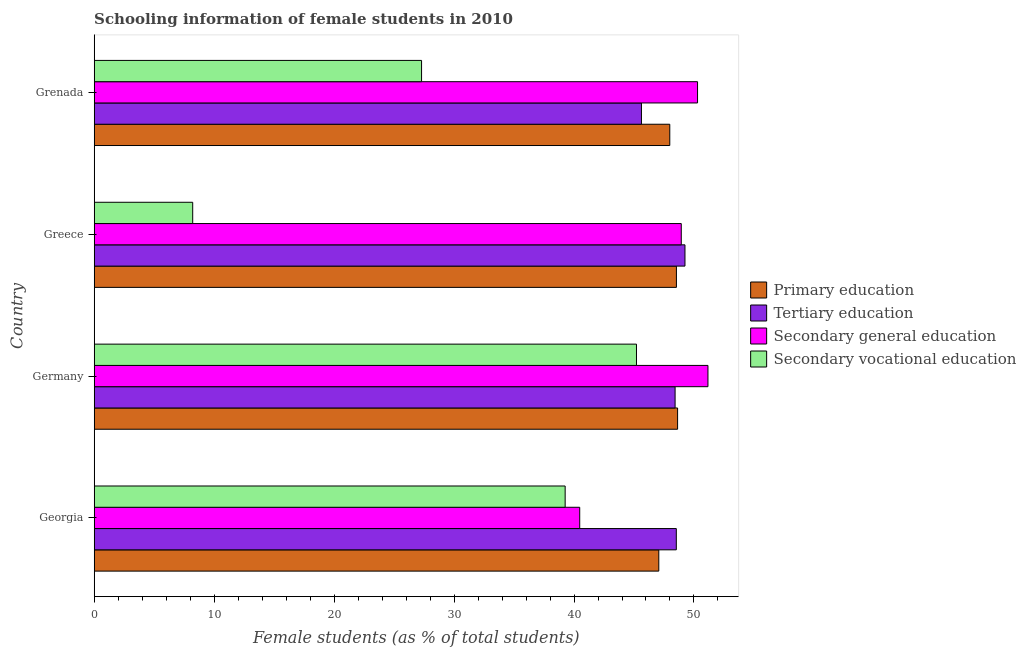How many different coloured bars are there?
Offer a terse response. 4. Are the number of bars per tick equal to the number of legend labels?
Offer a very short reply. Yes. Are the number of bars on each tick of the Y-axis equal?
Offer a terse response. Yes. What is the label of the 1st group of bars from the top?
Offer a terse response. Grenada. In how many cases, is the number of bars for a given country not equal to the number of legend labels?
Provide a short and direct response. 0. What is the percentage of female students in tertiary education in Germany?
Your answer should be compact. 48.43. Across all countries, what is the maximum percentage of female students in secondary vocational education?
Your answer should be very brief. 45.21. Across all countries, what is the minimum percentage of female students in primary education?
Provide a short and direct response. 47.07. In which country was the percentage of female students in secondary vocational education maximum?
Your answer should be compact. Germany. In which country was the percentage of female students in primary education minimum?
Your response must be concise. Georgia. What is the total percentage of female students in primary education in the graph?
Your answer should be compact. 192.22. What is the difference between the percentage of female students in tertiary education in Georgia and that in Greece?
Keep it short and to the point. -0.72. What is the difference between the percentage of female students in secondary education in Germany and the percentage of female students in tertiary education in Greece?
Offer a very short reply. 1.92. What is the average percentage of female students in secondary vocational education per country?
Make the answer very short. 29.99. What is the difference between the percentage of female students in secondary education and percentage of female students in primary education in Greece?
Provide a short and direct response. 0.4. What is the ratio of the percentage of female students in secondary education in Georgia to that in Germany?
Your answer should be compact. 0.79. What is the difference between the highest and the second highest percentage of female students in tertiary education?
Provide a short and direct response. 0.72. What is the difference between the highest and the lowest percentage of female students in primary education?
Offer a terse response. 1.57. In how many countries, is the percentage of female students in primary education greater than the average percentage of female students in primary education taken over all countries?
Offer a terse response. 2. Is the sum of the percentage of female students in secondary vocational education in Georgia and Grenada greater than the maximum percentage of female students in tertiary education across all countries?
Your response must be concise. Yes. Is it the case that in every country, the sum of the percentage of female students in secondary vocational education and percentage of female students in secondary education is greater than the sum of percentage of female students in tertiary education and percentage of female students in primary education?
Your response must be concise. No. What does the 1st bar from the top in Greece represents?
Offer a terse response. Secondary vocational education. Is it the case that in every country, the sum of the percentage of female students in primary education and percentage of female students in tertiary education is greater than the percentage of female students in secondary education?
Offer a very short reply. Yes. How many countries are there in the graph?
Your response must be concise. 4. Does the graph contain any zero values?
Offer a terse response. No. Where does the legend appear in the graph?
Give a very brief answer. Center right. How many legend labels are there?
Your answer should be compact. 4. How are the legend labels stacked?
Provide a short and direct response. Vertical. What is the title of the graph?
Ensure brevity in your answer.  Schooling information of female students in 2010. Does "Interest Payments" appear as one of the legend labels in the graph?
Keep it short and to the point. No. What is the label or title of the X-axis?
Offer a terse response. Female students (as % of total students). What is the label or title of the Y-axis?
Offer a very short reply. Country. What is the Female students (as % of total students) in Primary education in Georgia?
Provide a short and direct response. 47.07. What is the Female students (as % of total students) in Tertiary education in Georgia?
Provide a succinct answer. 48.53. What is the Female students (as % of total students) of Secondary general education in Georgia?
Your answer should be very brief. 40.47. What is the Female students (as % of total students) of Secondary vocational education in Georgia?
Your response must be concise. 39.26. What is the Female students (as % of total students) in Primary education in Germany?
Your answer should be very brief. 48.63. What is the Female students (as % of total students) of Tertiary education in Germany?
Your answer should be very brief. 48.43. What is the Female students (as % of total students) in Secondary general education in Germany?
Offer a terse response. 51.16. What is the Female students (as % of total students) of Secondary vocational education in Germany?
Provide a succinct answer. 45.21. What is the Female students (as % of total students) of Primary education in Greece?
Offer a very short reply. 48.54. What is the Female students (as % of total students) of Tertiary education in Greece?
Keep it short and to the point. 49.25. What is the Female students (as % of total students) of Secondary general education in Greece?
Make the answer very short. 48.94. What is the Female students (as % of total students) in Secondary vocational education in Greece?
Your answer should be very brief. 8.21. What is the Female students (as % of total students) of Primary education in Grenada?
Provide a succinct answer. 47.98. What is the Female students (as % of total students) in Tertiary education in Grenada?
Keep it short and to the point. 45.62. What is the Female students (as % of total students) in Secondary general education in Grenada?
Provide a short and direct response. 50.3. What is the Female students (as % of total students) of Secondary vocational education in Grenada?
Keep it short and to the point. 27.29. Across all countries, what is the maximum Female students (as % of total students) in Primary education?
Your response must be concise. 48.63. Across all countries, what is the maximum Female students (as % of total students) of Tertiary education?
Make the answer very short. 49.25. Across all countries, what is the maximum Female students (as % of total students) in Secondary general education?
Your answer should be compact. 51.16. Across all countries, what is the maximum Female students (as % of total students) of Secondary vocational education?
Provide a succinct answer. 45.21. Across all countries, what is the minimum Female students (as % of total students) in Primary education?
Keep it short and to the point. 47.07. Across all countries, what is the minimum Female students (as % of total students) of Tertiary education?
Offer a very short reply. 45.62. Across all countries, what is the minimum Female students (as % of total students) of Secondary general education?
Your response must be concise. 40.47. Across all countries, what is the minimum Female students (as % of total students) in Secondary vocational education?
Your answer should be compact. 8.21. What is the total Female students (as % of total students) in Primary education in the graph?
Keep it short and to the point. 192.22. What is the total Female students (as % of total students) of Tertiary education in the graph?
Offer a very short reply. 191.82. What is the total Female students (as % of total students) in Secondary general education in the graph?
Offer a very short reply. 190.88. What is the total Female students (as % of total students) of Secondary vocational education in the graph?
Your answer should be very brief. 119.97. What is the difference between the Female students (as % of total students) in Primary education in Georgia and that in Germany?
Your answer should be very brief. -1.57. What is the difference between the Female students (as % of total students) in Tertiary education in Georgia and that in Germany?
Give a very brief answer. 0.1. What is the difference between the Female students (as % of total students) of Secondary general education in Georgia and that in Germany?
Offer a terse response. -10.69. What is the difference between the Female students (as % of total students) in Secondary vocational education in Georgia and that in Germany?
Offer a terse response. -5.95. What is the difference between the Female students (as % of total students) in Primary education in Georgia and that in Greece?
Offer a terse response. -1.47. What is the difference between the Female students (as % of total students) in Tertiary education in Georgia and that in Greece?
Provide a succinct answer. -0.72. What is the difference between the Female students (as % of total students) in Secondary general education in Georgia and that in Greece?
Provide a short and direct response. -8.47. What is the difference between the Female students (as % of total students) in Secondary vocational education in Georgia and that in Greece?
Your answer should be compact. 31.05. What is the difference between the Female students (as % of total students) of Primary education in Georgia and that in Grenada?
Give a very brief answer. -0.92. What is the difference between the Female students (as % of total students) in Tertiary education in Georgia and that in Grenada?
Give a very brief answer. 2.91. What is the difference between the Female students (as % of total students) of Secondary general education in Georgia and that in Grenada?
Provide a short and direct response. -9.82. What is the difference between the Female students (as % of total students) in Secondary vocational education in Georgia and that in Grenada?
Keep it short and to the point. 11.97. What is the difference between the Female students (as % of total students) of Primary education in Germany and that in Greece?
Offer a terse response. 0.1. What is the difference between the Female students (as % of total students) in Tertiary education in Germany and that in Greece?
Ensure brevity in your answer.  -0.82. What is the difference between the Female students (as % of total students) in Secondary general education in Germany and that in Greece?
Give a very brief answer. 2.22. What is the difference between the Female students (as % of total students) of Secondary vocational education in Germany and that in Greece?
Your answer should be very brief. 36.99. What is the difference between the Female students (as % of total students) in Primary education in Germany and that in Grenada?
Provide a succinct answer. 0.65. What is the difference between the Female students (as % of total students) in Tertiary education in Germany and that in Grenada?
Your answer should be compact. 2.8. What is the difference between the Female students (as % of total students) in Secondary general education in Germany and that in Grenada?
Offer a terse response. 0.87. What is the difference between the Female students (as % of total students) of Secondary vocational education in Germany and that in Grenada?
Your response must be concise. 17.92. What is the difference between the Female students (as % of total students) of Primary education in Greece and that in Grenada?
Provide a succinct answer. 0.55. What is the difference between the Female students (as % of total students) in Tertiary education in Greece and that in Grenada?
Give a very brief answer. 3.63. What is the difference between the Female students (as % of total students) of Secondary general education in Greece and that in Grenada?
Provide a short and direct response. -1.36. What is the difference between the Female students (as % of total students) in Secondary vocational education in Greece and that in Grenada?
Provide a succinct answer. -19.08. What is the difference between the Female students (as % of total students) of Primary education in Georgia and the Female students (as % of total students) of Tertiary education in Germany?
Your response must be concise. -1.36. What is the difference between the Female students (as % of total students) in Primary education in Georgia and the Female students (as % of total students) in Secondary general education in Germany?
Your answer should be very brief. -4.1. What is the difference between the Female students (as % of total students) in Primary education in Georgia and the Female students (as % of total students) in Secondary vocational education in Germany?
Your response must be concise. 1.86. What is the difference between the Female students (as % of total students) of Tertiary education in Georgia and the Female students (as % of total students) of Secondary general education in Germany?
Ensure brevity in your answer.  -2.64. What is the difference between the Female students (as % of total students) of Tertiary education in Georgia and the Female students (as % of total students) of Secondary vocational education in Germany?
Your answer should be very brief. 3.32. What is the difference between the Female students (as % of total students) in Secondary general education in Georgia and the Female students (as % of total students) in Secondary vocational education in Germany?
Offer a very short reply. -4.73. What is the difference between the Female students (as % of total students) in Primary education in Georgia and the Female students (as % of total students) in Tertiary education in Greece?
Give a very brief answer. -2.18. What is the difference between the Female students (as % of total students) of Primary education in Georgia and the Female students (as % of total students) of Secondary general education in Greece?
Provide a succinct answer. -1.87. What is the difference between the Female students (as % of total students) of Primary education in Georgia and the Female students (as % of total students) of Secondary vocational education in Greece?
Give a very brief answer. 38.85. What is the difference between the Female students (as % of total students) in Tertiary education in Georgia and the Female students (as % of total students) in Secondary general education in Greece?
Your answer should be very brief. -0.41. What is the difference between the Female students (as % of total students) in Tertiary education in Georgia and the Female students (as % of total students) in Secondary vocational education in Greece?
Give a very brief answer. 40.31. What is the difference between the Female students (as % of total students) in Secondary general education in Georgia and the Female students (as % of total students) in Secondary vocational education in Greece?
Ensure brevity in your answer.  32.26. What is the difference between the Female students (as % of total students) of Primary education in Georgia and the Female students (as % of total students) of Tertiary education in Grenada?
Provide a short and direct response. 1.45. What is the difference between the Female students (as % of total students) in Primary education in Georgia and the Female students (as % of total students) in Secondary general education in Grenada?
Keep it short and to the point. -3.23. What is the difference between the Female students (as % of total students) of Primary education in Georgia and the Female students (as % of total students) of Secondary vocational education in Grenada?
Your answer should be very brief. 19.78. What is the difference between the Female students (as % of total students) in Tertiary education in Georgia and the Female students (as % of total students) in Secondary general education in Grenada?
Offer a terse response. -1.77. What is the difference between the Female students (as % of total students) in Tertiary education in Georgia and the Female students (as % of total students) in Secondary vocational education in Grenada?
Offer a very short reply. 21.24. What is the difference between the Female students (as % of total students) of Secondary general education in Georgia and the Female students (as % of total students) of Secondary vocational education in Grenada?
Offer a terse response. 13.18. What is the difference between the Female students (as % of total students) in Primary education in Germany and the Female students (as % of total students) in Tertiary education in Greece?
Provide a succinct answer. -0.61. What is the difference between the Female students (as % of total students) in Primary education in Germany and the Female students (as % of total students) in Secondary general education in Greece?
Keep it short and to the point. -0.31. What is the difference between the Female students (as % of total students) in Primary education in Germany and the Female students (as % of total students) in Secondary vocational education in Greece?
Provide a succinct answer. 40.42. What is the difference between the Female students (as % of total students) in Tertiary education in Germany and the Female students (as % of total students) in Secondary general education in Greece?
Give a very brief answer. -0.52. What is the difference between the Female students (as % of total students) in Tertiary education in Germany and the Female students (as % of total students) in Secondary vocational education in Greece?
Offer a terse response. 40.21. What is the difference between the Female students (as % of total students) in Secondary general education in Germany and the Female students (as % of total students) in Secondary vocational education in Greece?
Keep it short and to the point. 42.95. What is the difference between the Female students (as % of total students) in Primary education in Germany and the Female students (as % of total students) in Tertiary education in Grenada?
Your answer should be compact. 3.01. What is the difference between the Female students (as % of total students) of Primary education in Germany and the Female students (as % of total students) of Secondary general education in Grenada?
Provide a short and direct response. -1.66. What is the difference between the Female students (as % of total students) of Primary education in Germany and the Female students (as % of total students) of Secondary vocational education in Grenada?
Keep it short and to the point. 21.34. What is the difference between the Female students (as % of total students) in Tertiary education in Germany and the Female students (as % of total students) in Secondary general education in Grenada?
Give a very brief answer. -1.87. What is the difference between the Female students (as % of total students) of Tertiary education in Germany and the Female students (as % of total students) of Secondary vocational education in Grenada?
Provide a succinct answer. 21.14. What is the difference between the Female students (as % of total students) in Secondary general education in Germany and the Female students (as % of total students) in Secondary vocational education in Grenada?
Keep it short and to the point. 23.87. What is the difference between the Female students (as % of total students) of Primary education in Greece and the Female students (as % of total students) of Tertiary education in Grenada?
Offer a very short reply. 2.92. What is the difference between the Female students (as % of total students) of Primary education in Greece and the Female students (as % of total students) of Secondary general education in Grenada?
Your response must be concise. -1.76. What is the difference between the Female students (as % of total students) of Primary education in Greece and the Female students (as % of total students) of Secondary vocational education in Grenada?
Provide a succinct answer. 21.25. What is the difference between the Female students (as % of total students) of Tertiary education in Greece and the Female students (as % of total students) of Secondary general education in Grenada?
Provide a succinct answer. -1.05. What is the difference between the Female students (as % of total students) in Tertiary education in Greece and the Female students (as % of total students) in Secondary vocational education in Grenada?
Offer a terse response. 21.96. What is the difference between the Female students (as % of total students) in Secondary general education in Greece and the Female students (as % of total students) in Secondary vocational education in Grenada?
Your answer should be compact. 21.65. What is the average Female students (as % of total students) in Primary education per country?
Provide a short and direct response. 48.06. What is the average Female students (as % of total students) of Tertiary education per country?
Your answer should be very brief. 47.96. What is the average Female students (as % of total students) of Secondary general education per country?
Ensure brevity in your answer.  47.72. What is the average Female students (as % of total students) in Secondary vocational education per country?
Provide a short and direct response. 29.99. What is the difference between the Female students (as % of total students) of Primary education and Female students (as % of total students) of Tertiary education in Georgia?
Ensure brevity in your answer.  -1.46. What is the difference between the Female students (as % of total students) in Primary education and Female students (as % of total students) in Secondary general education in Georgia?
Your answer should be compact. 6.59. What is the difference between the Female students (as % of total students) in Primary education and Female students (as % of total students) in Secondary vocational education in Georgia?
Offer a terse response. 7.81. What is the difference between the Female students (as % of total students) of Tertiary education and Female students (as % of total students) of Secondary general education in Georgia?
Offer a very short reply. 8.05. What is the difference between the Female students (as % of total students) in Tertiary education and Female students (as % of total students) in Secondary vocational education in Georgia?
Offer a terse response. 9.27. What is the difference between the Female students (as % of total students) of Secondary general education and Female students (as % of total students) of Secondary vocational education in Georgia?
Ensure brevity in your answer.  1.21. What is the difference between the Female students (as % of total students) of Primary education and Female students (as % of total students) of Tertiary education in Germany?
Provide a succinct answer. 0.21. What is the difference between the Female students (as % of total students) in Primary education and Female students (as % of total students) in Secondary general education in Germany?
Your answer should be compact. -2.53. What is the difference between the Female students (as % of total students) of Primary education and Female students (as % of total students) of Secondary vocational education in Germany?
Give a very brief answer. 3.43. What is the difference between the Female students (as % of total students) of Tertiary education and Female students (as % of total students) of Secondary general education in Germany?
Make the answer very short. -2.74. What is the difference between the Female students (as % of total students) of Tertiary education and Female students (as % of total students) of Secondary vocational education in Germany?
Your response must be concise. 3.22. What is the difference between the Female students (as % of total students) of Secondary general education and Female students (as % of total students) of Secondary vocational education in Germany?
Ensure brevity in your answer.  5.96. What is the difference between the Female students (as % of total students) of Primary education and Female students (as % of total students) of Tertiary education in Greece?
Your response must be concise. -0.71. What is the difference between the Female students (as % of total students) in Primary education and Female students (as % of total students) in Secondary general education in Greece?
Your answer should be very brief. -0.4. What is the difference between the Female students (as % of total students) of Primary education and Female students (as % of total students) of Secondary vocational education in Greece?
Give a very brief answer. 40.33. What is the difference between the Female students (as % of total students) of Tertiary education and Female students (as % of total students) of Secondary general education in Greece?
Give a very brief answer. 0.31. What is the difference between the Female students (as % of total students) in Tertiary education and Female students (as % of total students) in Secondary vocational education in Greece?
Provide a succinct answer. 41.04. What is the difference between the Female students (as % of total students) in Secondary general education and Female students (as % of total students) in Secondary vocational education in Greece?
Your answer should be very brief. 40.73. What is the difference between the Female students (as % of total students) of Primary education and Female students (as % of total students) of Tertiary education in Grenada?
Offer a terse response. 2.36. What is the difference between the Female students (as % of total students) in Primary education and Female students (as % of total students) in Secondary general education in Grenada?
Provide a succinct answer. -2.31. What is the difference between the Female students (as % of total students) in Primary education and Female students (as % of total students) in Secondary vocational education in Grenada?
Give a very brief answer. 20.69. What is the difference between the Female students (as % of total students) of Tertiary education and Female students (as % of total students) of Secondary general education in Grenada?
Provide a short and direct response. -4.68. What is the difference between the Female students (as % of total students) of Tertiary education and Female students (as % of total students) of Secondary vocational education in Grenada?
Your answer should be compact. 18.33. What is the difference between the Female students (as % of total students) in Secondary general education and Female students (as % of total students) in Secondary vocational education in Grenada?
Offer a terse response. 23.01. What is the ratio of the Female students (as % of total students) of Primary education in Georgia to that in Germany?
Provide a succinct answer. 0.97. What is the ratio of the Female students (as % of total students) of Tertiary education in Georgia to that in Germany?
Provide a short and direct response. 1. What is the ratio of the Female students (as % of total students) of Secondary general education in Georgia to that in Germany?
Your response must be concise. 0.79. What is the ratio of the Female students (as % of total students) of Secondary vocational education in Georgia to that in Germany?
Offer a very short reply. 0.87. What is the ratio of the Female students (as % of total students) of Primary education in Georgia to that in Greece?
Keep it short and to the point. 0.97. What is the ratio of the Female students (as % of total students) of Secondary general education in Georgia to that in Greece?
Keep it short and to the point. 0.83. What is the ratio of the Female students (as % of total students) in Secondary vocational education in Georgia to that in Greece?
Make the answer very short. 4.78. What is the ratio of the Female students (as % of total students) in Primary education in Georgia to that in Grenada?
Provide a succinct answer. 0.98. What is the ratio of the Female students (as % of total students) in Tertiary education in Georgia to that in Grenada?
Your answer should be compact. 1.06. What is the ratio of the Female students (as % of total students) of Secondary general education in Georgia to that in Grenada?
Provide a succinct answer. 0.8. What is the ratio of the Female students (as % of total students) in Secondary vocational education in Georgia to that in Grenada?
Offer a very short reply. 1.44. What is the ratio of the Female students (as % of total students) of Primary education in Germany to that in Greece?
Give a very brief answer. 1. What is the ratio of the Female students (as % of total students) of Tertiary education in Germany to that in Greece?
Provide a succinct answer. 0.98. What is the ratio of the Female students (as % of total students) of Secondary general education in Germany to that in Greece?
Provide a succinct answer. 1.05. What is the ratio of the Female students (as % of total students) of Secondary vocational education in Germany to that in Greece?
Keep it short and to the point. 5.5. What is the ratio of the Female students (as % of total students) of Primary education in Germany to that in Grenada?
Your response must be concise. 1.01. What is the ratio of the Female students (as % of total students) of Tertiary education in Germany to that in Grenada?
Ensure brevity in your answer.  1.06. What is the ratio of the Female students (as % of total students) of Secondary general education in Germany to that in Grenada?
Offer a terse response. 1.02. What is the ratio of the Female students (as % of total students) of Secondary vocational education in Germany to that in Grenada?
Provide a succinct answer. 1.66. What is the ratio of the Female students (as % of total students) in Primary education in Greece to that in Grenada?
Offer a very short reply. 1.01. What is the ratio of the Female students (as % of total students) of Tertiary education in Greece to that in Grenada?
Provide a short and direct response. 1.08. What is the ratio of the Female students (as % of total students) in Secondary vocational education in Greece to that in Grenada?
Offer a very short reply. 0.3. What is the difference between the highest and the second highest Female students (as % of total students) in Primary education?
Make the answer very short. 0.1. What is the difference between the highest and the second highest Female students (as % of total students) of Tertiary education?
Your answer should be compact. 0.72. What is the difference between the highest and the second highest Female students (as % of total students) in Secondary general education?
Keep it short and to the point. 0.87. What is the difference between the highest and the second highest Female students (as % of total students) in Secondary vocational education?
Ensure brevity in your answer.  5.95. What is the difference between the highest and the lowest Female students (as % of total students) of Primary education?
Keep it short and to the point. 1.57. What is the difference between the highest and the lowest Female students (as % of total students) of Tertiary education?
Your response must be concise. 3.63. What is the difference between the highest and the lowest Female students (as % of total students) of Secondary general education?
Make the answer very short. 10.69. What is the difference between the highest and the lowest Female students (as % of total students) of Secondary vocational education?
Offer a terse response. 36.99. 